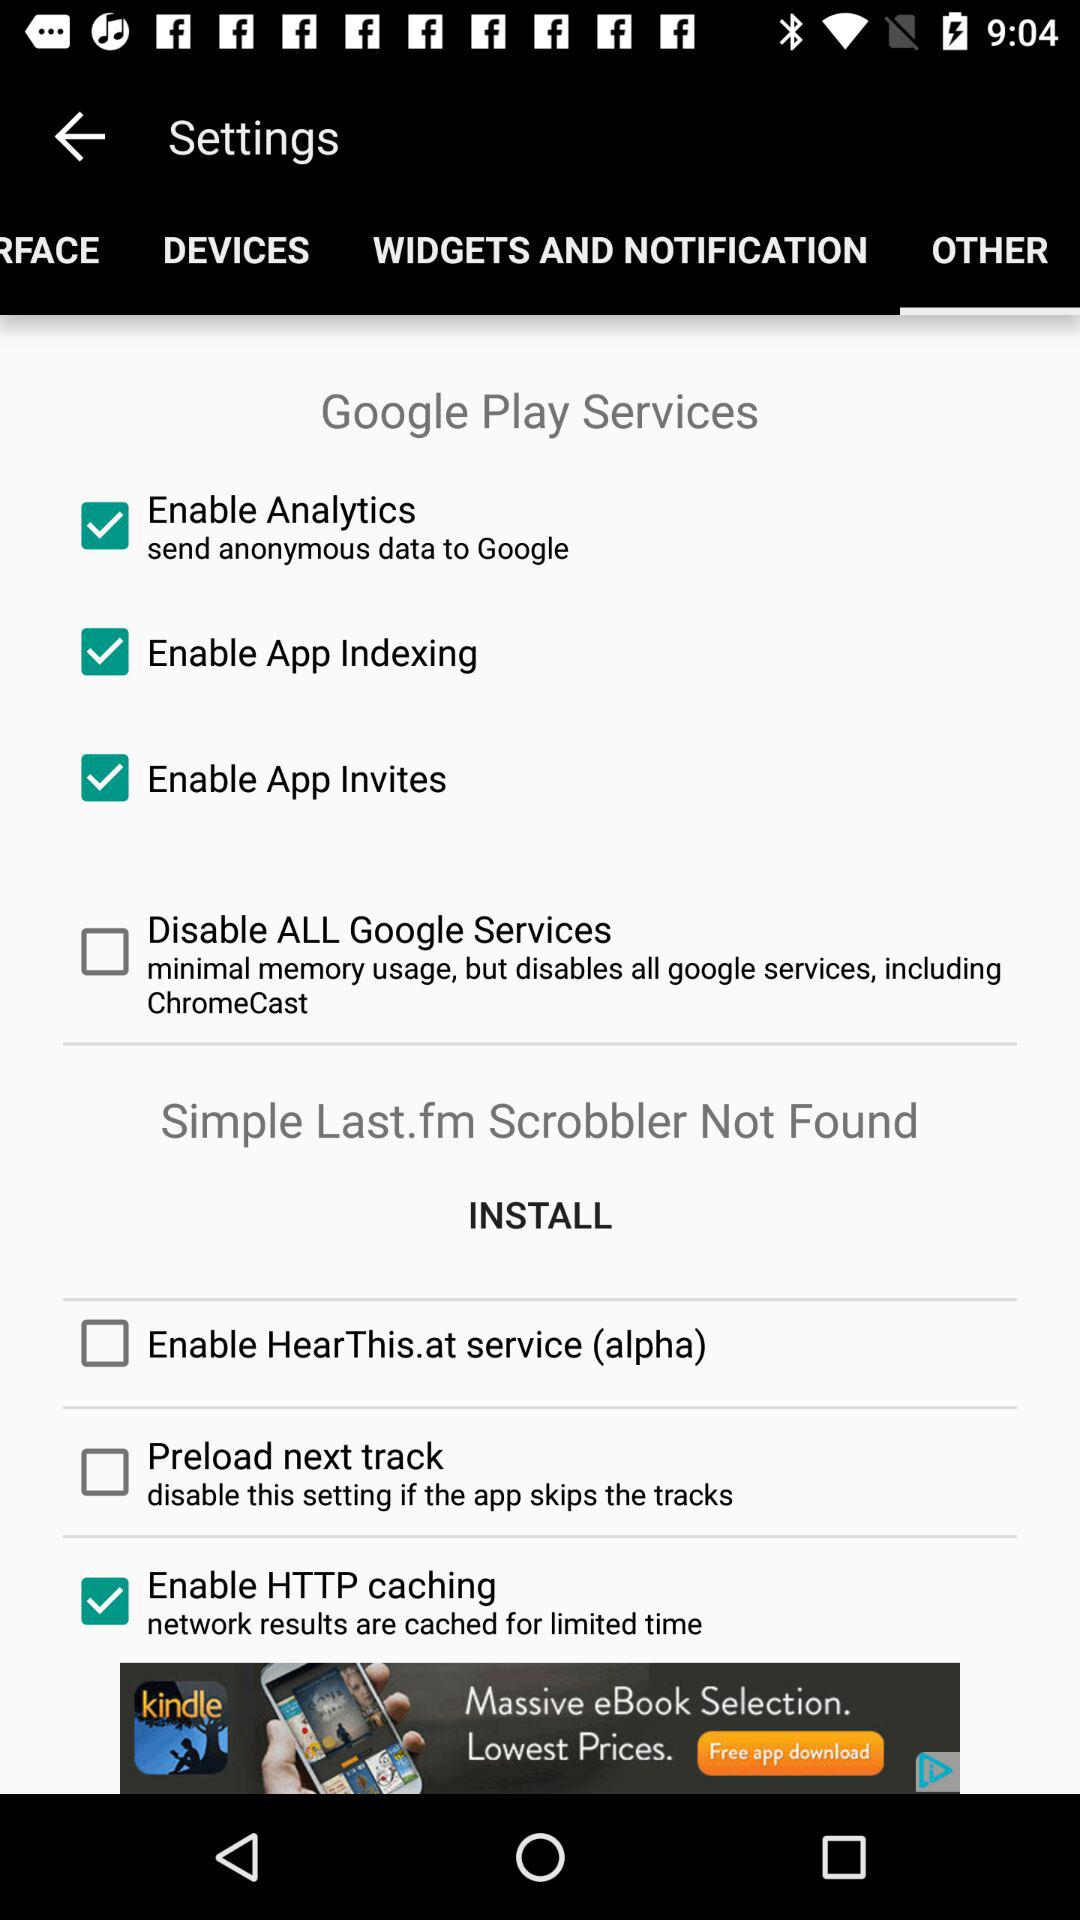Which tab has been selected? The selected tab is "OTHER". 